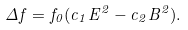<formula> <loc_0><loc_0><loc_500><loc_500>\Delta f = f _ { 0 } ( c _ { 1 } E ^ { 2 } - c _ { 2 } B ^ { 2 } ) .</formula> 